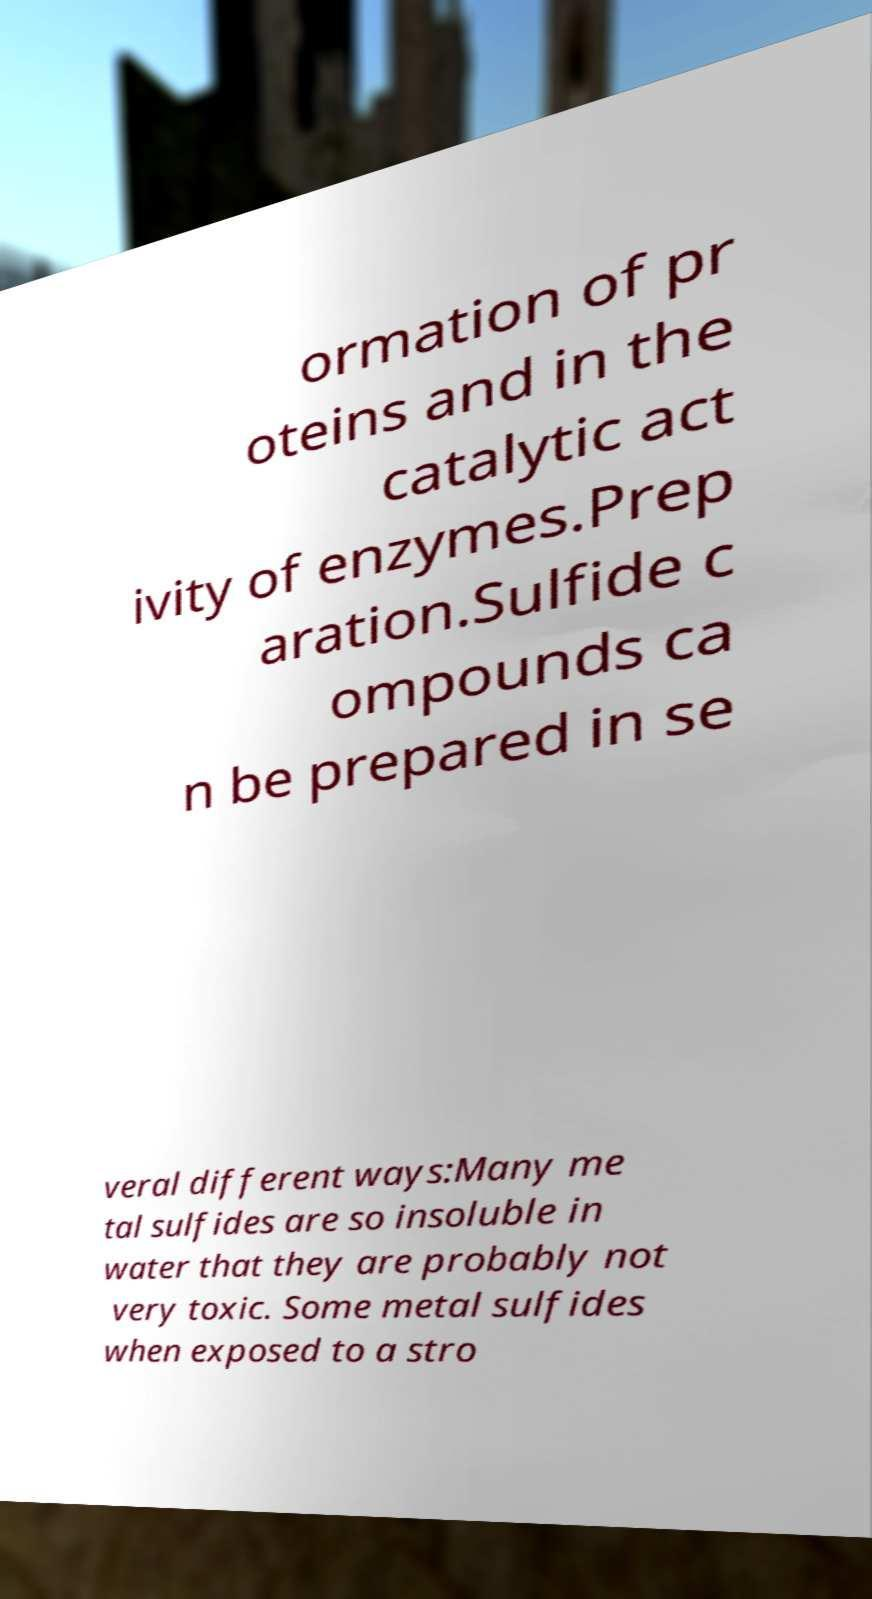I need the written content from this picture converted into text. Can you do that? ormation of pr oteins and in the catalytic act ivity of enzymes.Prep aration.Sulfide c ompounds ca n be prepared in se veral different ways:Many me tal sulfides are so insoluble in water that they are probably not very toxic. Some metal sulfides when exposed to a stro 